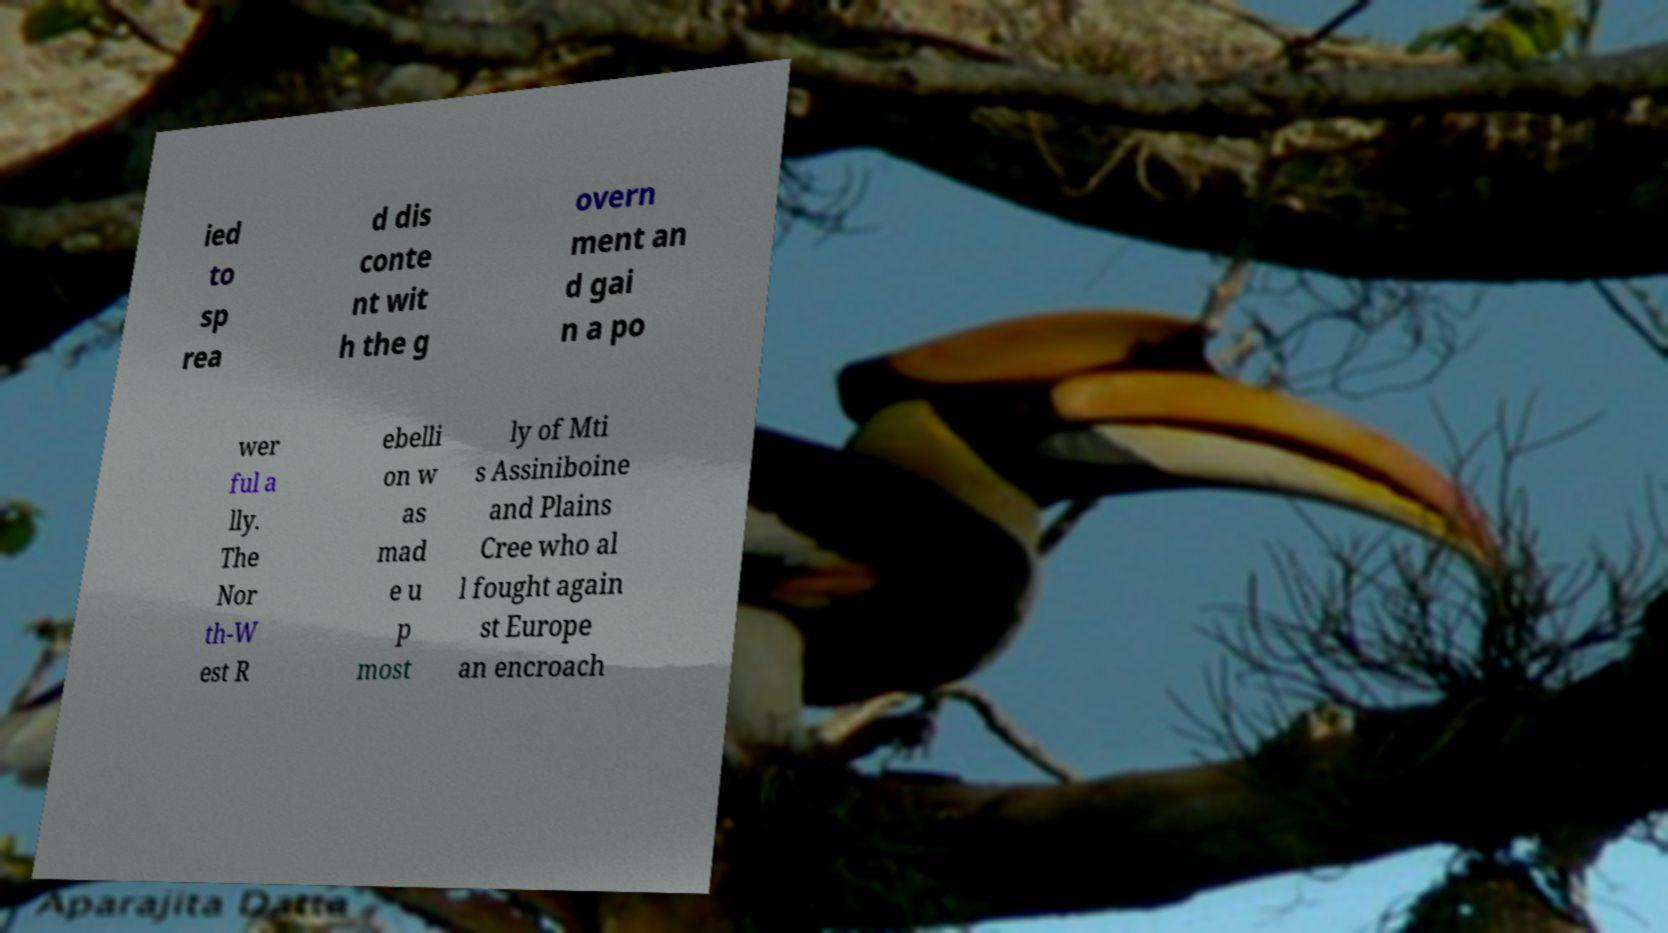Please identify and transcribe the text found in this image. ied to sp rea d dis conte nt wit h the g overn ment an d gai n a po wer ful a lly. The Nor th-W est R ebelli on w as mad e u p most ly of Mti s Assiniboine and Plains Cree who al l fought again st Europe an encroach 